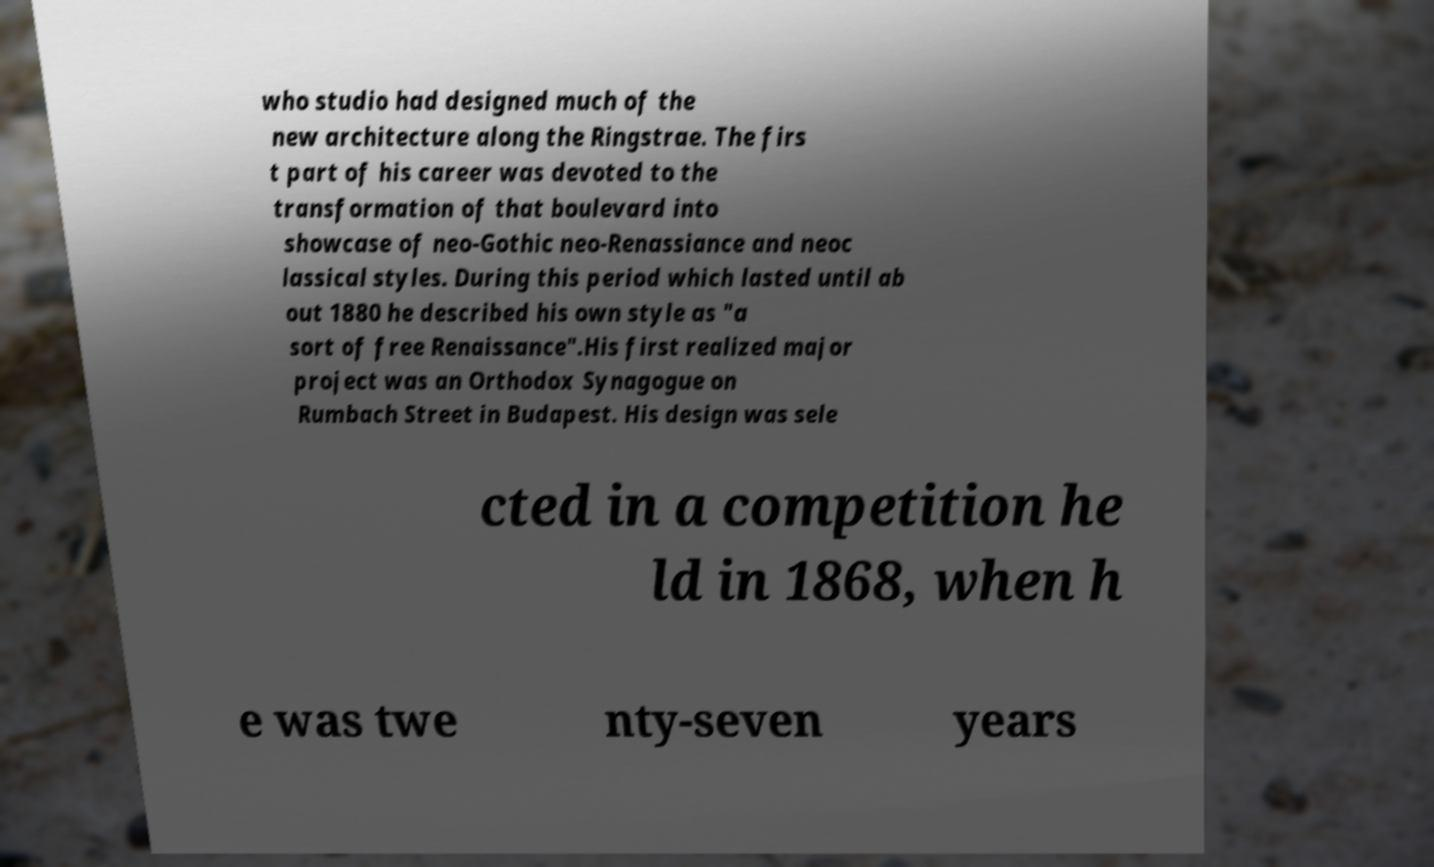There's text embedded in this image that I need extracted. Can you transcribe it verbatim? who studio had designed much of the new architecture along the Ringstrae. The firs t part of his career was devoted to the transformation of that boulevard into showcase of neo-Gothic neo-Renassiance and neoc lassical styles. During this period which lasted until ab out 1880 he described his own style as "a sort of free Renaissance".His first realized major project was an Orthodox Synagogue on Rumbach Street in Budapest. His design was sele cted in a competition he ld in 1868, when h e was twe nty-seven years 